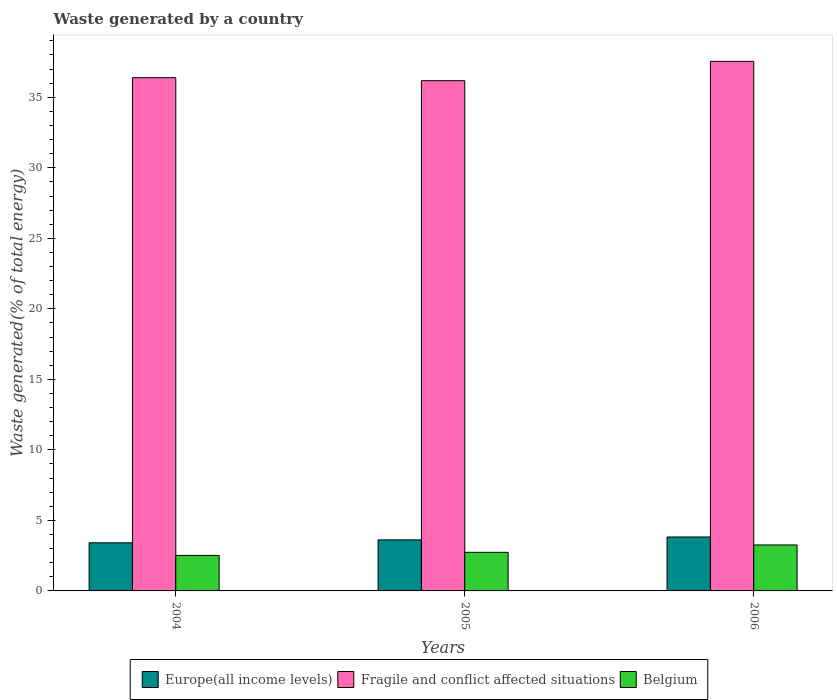How many different coloured bars are there?
Give a very brief answer. 3. How many groups of bars are there?
Give a very brief answer. 3. Are the number of bars on each tick of the X-axis equal?
Make the answer very short. Yes. How many bars are there on the 3rd tick from the left?
Ensure brevity in your answer.  3. What is the label of the 3rd group of bars from the left?
Keep it short and to the point. 2006. What is the total waste generated in Fragile and conflict affected situations in 2005?
Ensure brevity in your answer.  36.18. Across all years, what is the maximum total waste generated in Fragile and conflict affected situations?
Provide a short and direct response. 37.55. Across all years, what is the minimum total waste generated in Fragile and conflict affected situations?
Offer a terse response. 36.18. What is the total total waste generated in Fragile and conflict affected situations in the graph?
Ensure brevity in your answer.  110.12. What is the difference between the total waste generated in Fragile and conflict affected situations in 2005 and that in 2006?
Provide a succinct answer. -1.37. What is the difference between the total waste generated in Fragile and conflict affected situations in 2005 and the total waste generated in Belgium in 2004?
Your answer should be very brief. 33.66. What is the average total waste generated in Europe(all income levels) per year?
Provide a short and direct response. 3.62. In the year 2004, what is the difference between the total waste generated in Belgium and total waste generated in Europe(all income levels)?
Keep it short and to the point. -0.9. In how many years, is the total waste generated in Fragile and conflict affected situations greater than 21 %?
Your answer should be very brief. 3. What is the ratio of the total waste generated in Fragile and conflict affected situations in 2004 to that in 2005?
Ensure brevity in your answer.  1.01. Is the total waste generated in Fragile and conflict affected situations in 2004 less than that in 2005?
Provide a succinct answer. No. Is the difference between the total waste generated in Belgium in 2004 and 2006 greater than the difference between the total waste generated in Europe(all income levels) in 2004 and 2006?
Provide a succinct answer. No. What is the difference between the highest and the second highest total waste generated in Europe(all income levels)?
Offer a terse response. 0.21. What is the difference between the highest and the lowest total waste generated in Europe(all income levels)?
Your answer should be very brief. 0.41. In how many years, is the total waste generated in Europe(all income levels) greater than the average total waste generated in Europe(all income levels) taken over all years?
Provide a succinct answer. 2. What does the 2nd bar from the left in 2006 represents?
Give a very brief answer. Fragile and conflict affected situations. What does the 2nd bar from the right in 2006 represents?
Your answer should be very brief. Fragile and conflict affected situations. Is it the case that in every year, the sum of the total waste generated in Fragile and conflict affected situations and total waste generated in Belgium is greater than the total waste generated in Europe(all income levels)?
Give a very brief answer. Yes. Are the values on the major ticks of Y-axis written in scientific E-notation?
Your answer should be compact. No. Does the graph contain grids?
Ensure brevity in your answer.  No. How are the legend labels stacked?
Your answer should be compact. Horizontal. What is the title of the graph?
Provide a short and direct response. Waste generated by a country. Does "Algeria" appear as one of the legend labels in the graph?
Give a very brief answer. No. What is the label or title of the X-axis?
Keep it short and to the point. Years. What is the label or title of the Y-axis?
Keep it short and to the point. Waste generated(% of total energy). What is the Waste generated(% of total energy) of Europe(all income levels) in 2004?
Your answer should be very brief. 3.41. What is the Waste generated(% of total energy) of Fragile and conflict affected situations in 2004?
Your answer should be compact. 36.39. What is the Waste generated(% of total energy) in Belgium in 2004?
Ensure brevity in your answer.  2.52. What is the Waste generated(% of total energy) of Europe(all income levels) in 2005?
Keep it short and to the point. 3.62. What is the Waste generated(% of total energy) in Fragile and conflict affected situations in 2005?
Provide a short and direct response. 36.18. What is the Waste generated(% of total energy) of Belgium in 2005?
Offer a very short reply. 2.74. What is the Waste generated(% of total energy) in Europe(all income levels) in 2006?
Offer a terse response. 3.82. What is the Waste generated(% of total energy) of Fragile and conflict affected situations in 2006?
Keep it short and to the point. 37.55. What is the Waste generated(% of total energy) in Belgium in 2006?
Offer a very short reply. 3.26. Across all years, what is the maximum Waste generated(% of total energy) in Europe(all income levels)?
Keep it short and to the point. 3.82. Across all years, what is the maximum Waste generated(% of total energy) in Fragile and conflict affected situations?
Provide a succinct answer. 37.55. Across all years, what is the maximum Waste generated(% of total energy) in Belgium?
Ensure brevity in your answer.  3.26. Across all years, what is the minimum Waste generated(% of total energy) of Europe(all income levels)?
Keep it short and to the point. 3.41. Across all years, what is the minimum Waste generated(% of total energy) in Fragile and conflict affected situations?
Your response must be concise. 36.18. Across all years, what is the minimum Waste generated(% of total energy) in Belgium?
Your response must be concise. 2.52. What is the total Waste generated(% of total energy) in Europe(all income levels) in the graph?
Make the answer very short. 10.86. What is the total Waste generated(% of total energy) of Fragile and conflict affected situations in the graph?
Your answer should be very brief. 110.12. What is the total Waste generated(% of total energy) in Belgium in the graph?
Provide a short and direct response. 8.51. What is the difference between the Waste generated(% of total energy) of Europe(all income levels) in 2004 and that in 2005?
Your answer should be compact. -0.21. What is the difference between the Waste generated(% of total energy) in Fragile and conflict affected situations in 2004 and that in 2005?
Offer a terse response. 0.22. What is the difference between the Waste generated(% of total energy) of Belgium in 2004 and that in 2005?
Your answer should be very brief. -0.22. What is the difference between the Waste generated(% of total energy) of Europe(all income levels) in 2004 and that in 2006?
Your answer should be very brief. -0.41. What is the difference between the Waste generated(% of total energy) of Fragile and conflict affected situations in 2004 and that in 2006?
Your answer should be very brief. -1.16. What is the difference between the Waste generated(% of total energy) of Belgium in 2004 and that in 2006?
Ensure brevity in your answer.  -0.74. What is the difference between the Waste generated(% of total energy) of Europe(all income levels) in 2005 and that in 2006?
Your answer should be compact. -0.21. What is the difference between the Waste generated(% of total energy) in Fragile and conflict affected situations in 2005 and that in 2006?
Offer a terse response. -1.37. What is the difference between the Waste generated(% of total energy) of Belgium in 2005 and that in 2006?
Provide a short and direct response. -0.52. What is the difference between the Waste generated(% of total energy) of Europe(all income levels) in 2004 and the Waste generated(% of total energy) of Fragile and conflict affected situations in 2005?
Give a very brief answer. -32.76. What is the difference between the Waste generated(% of total energy) in Europe(all income levels) in 2004 and the Waste generated(% of total energy) in Belgium in 2005?
Keep it short and to the point. 0.68. What is the difference between the Waste generated(% of total energy) of Fragile and conflict affected situations in 2004 and the Waste generated(% of total energy) of Belgium in 2005?
Your answer should be very brief. 33.66. What is the difference between the Waste generated(% of total energy) in Europe(all income levels) in 2004 and the Waste generated(% of total energy) in Fragile and conflict affected situations in 2006?
Provide a succinct answer. -34.14. What is the difference between the Waste generated(% of total energy) of Europe(all income levels) in 2004 and the Waste generated(% of total energy) of Belgium in 2006?
Make the answer very short. 0.15. What is the difference between the Waste generated(% of total energy) of Fragile and conflict affected situations in 2004 and the Waste generated(% of total energy) of Belgium in 2006?
Your answer should be very brief. 33.13. What is the difference between the Waste generated(% of total energy) in Europe(all income levels) in 2005 and the Waste generated(% of total energy) in Fragile and conflict affected situations in 2006?
Offer a terse response. -33.93. What is the difference between the Waste generated(% of total energy) of Europe(all income levels) in 2005 and the Waste generated(% of total energy) of Belgium in 2006?
Provide a short and direct response. 0.36. What is the difference between the Waste generated(% of total energy) in Fragile and conflict affected situations in 2005 and the Waste generated(% of total energy) in Belgium in 2006?
Provide a short and direct response. 32.92. What is the average Waste generated(% of total energy) of Europe(all income levels) per year?
Provide a succinct answer. 3.62. What is the average Waste generated(% of total energy) of Fragile and conflict affected situations per year?
Offer a very short reply. 36.71. What is the average Waste generated(% of total energy) in Belgium per year?
Ensure brevity in your answer.  2.84. In the year 2004, what is the difference between the Waste generated(% of total energy) in Europe(all income levels) and Waste generated(% of total energy) in Fragile and conflict affected situations?
Your answer should be compact. -32.98. In the year 2004, what is the difference between the Waste generated(% of total energy) of Europe(all income levels) and Waste generated(% of total energy) of Belgium?
Offer a very short reply. 0.9. In the year 2004, what is the difference between the Waste generated(% of total energy) in Fragile and conflict affected situations and Waste generated(% of total energy) in Belgium?
Your answer should be compact. 33.88. In the year 2005, what is the difference between the Waste generated(% of total energy) of Europe(all income levels) and Waste generated(% of total energy) of Fragile and conflict affected situations?
Offer a very short reply. -32.56. In the year 2005, what is the difference between the Waste generated(% of total energy) of Europe(all income levels) and Waste generated(% of total energy) of Belgium?
Offer a very short reply. 0.88. In the year 2005, what is the difference between the Waste generated(% of total energy) in Fragile and conflict affected situations and Waste generated(% of total energy) in Belgium?
Keep it short and to the point. 33.44. In the year 2006, what is the difference between the Waste generated(% of total energy) in Europe(all income levels) and Waste generated(% of total energy) in Fragile and conflict affected situations?
Make the answer very short. -33.72. In the year 2006, what is the difference between the Waste generated(% of total energy) in Europe(all income levels) and Waste generated(% of total energy) in Belgium?
Make the answer very short. 0.57. In the year 2006, what is the difference between the Waste generated(% of total energy) in Fragile and conflict affected situations and Waste generated(% of total energy) in Belgium?
Offer a terse response. 34.29. What is the ratio of the Waste generated(% of total energy) of Europe(all income levels) in 2004 to that in 2005?
Ensure brevity in your answer.  0.94. What is the ratio of the Waste generated(% of total energy) in Fragile and conflict affected situations in 2004 to that in 2005?
Your response must be concise. 1.01. What is the ratio of the Waste generated(% of total energy) in Belgium in 2004 to that in 2005?
Give a very brief answer. 0.92. What is the ratio of the Waste generated(% of total energy) of Europe(all income levels) in 2004 to that in 2006?
Offer a very short reply. 0.89. What is the ratio of the Waste generated(% of total energy) of Fragile and conflict affected situations in 2004 to that in 2006?
Your answer should be compact. 0.97. What is the ratio of the Waste generated(% of total energy) in Belgium in 2004 to that in 2006?
Your answer should be very brief. 0.77. What is the ratio of the Waste generated(% of total energy) in Europe(all income levels) in 2005 to that in 2006?
Provide a short and direct response. 0.95. What is the ratio of the Waste generated(% of total energy) in Fragile and conflict affected situations in 2005 to that in 2006?
Ensure brevity in your answer.  0.96. What is the ratio of the Waste generated(% of total energy) in Belgium in 2005 to that in 2006?
Offer a terse response. 0.84. What is the difference between the highest and the second highest Waste generated(% of total energy) in Europe(all income levels)?
Offer a terse response. 0.21. What is the difference between the highest and the second highest Waste generated(% of total energy) in Fragile and conflict affected situations?
Provide a short and direct response. 1.16. What is the difference between the highest and the second highest Waste generated(% of total energy) in Belgium?
Give a very brief answer. 0.52. What is the difference between the highest and the lowest Waste generated(% of total energy) of Europe(all income levels)?
Offer a very short reply. 0.41. What is the difference between the highest and the lowest Waste generated(% of total energy) in Fragile and conflict affected situations?
Ensure brevity in your answer.  1.37. What is the difference between the highest and the lowest Waste generated(% of total energy) in Belgium?
Ensure brevity in your answer.  0.74. 